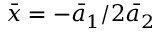Convert formula to latex. <formula><loc_0><loc_0><loc_500><loc_500>\bar { x } = - { { \bar { a } } _ { 1 } } / 2 { { \bar { a } } _ { 2 } }</formula> 